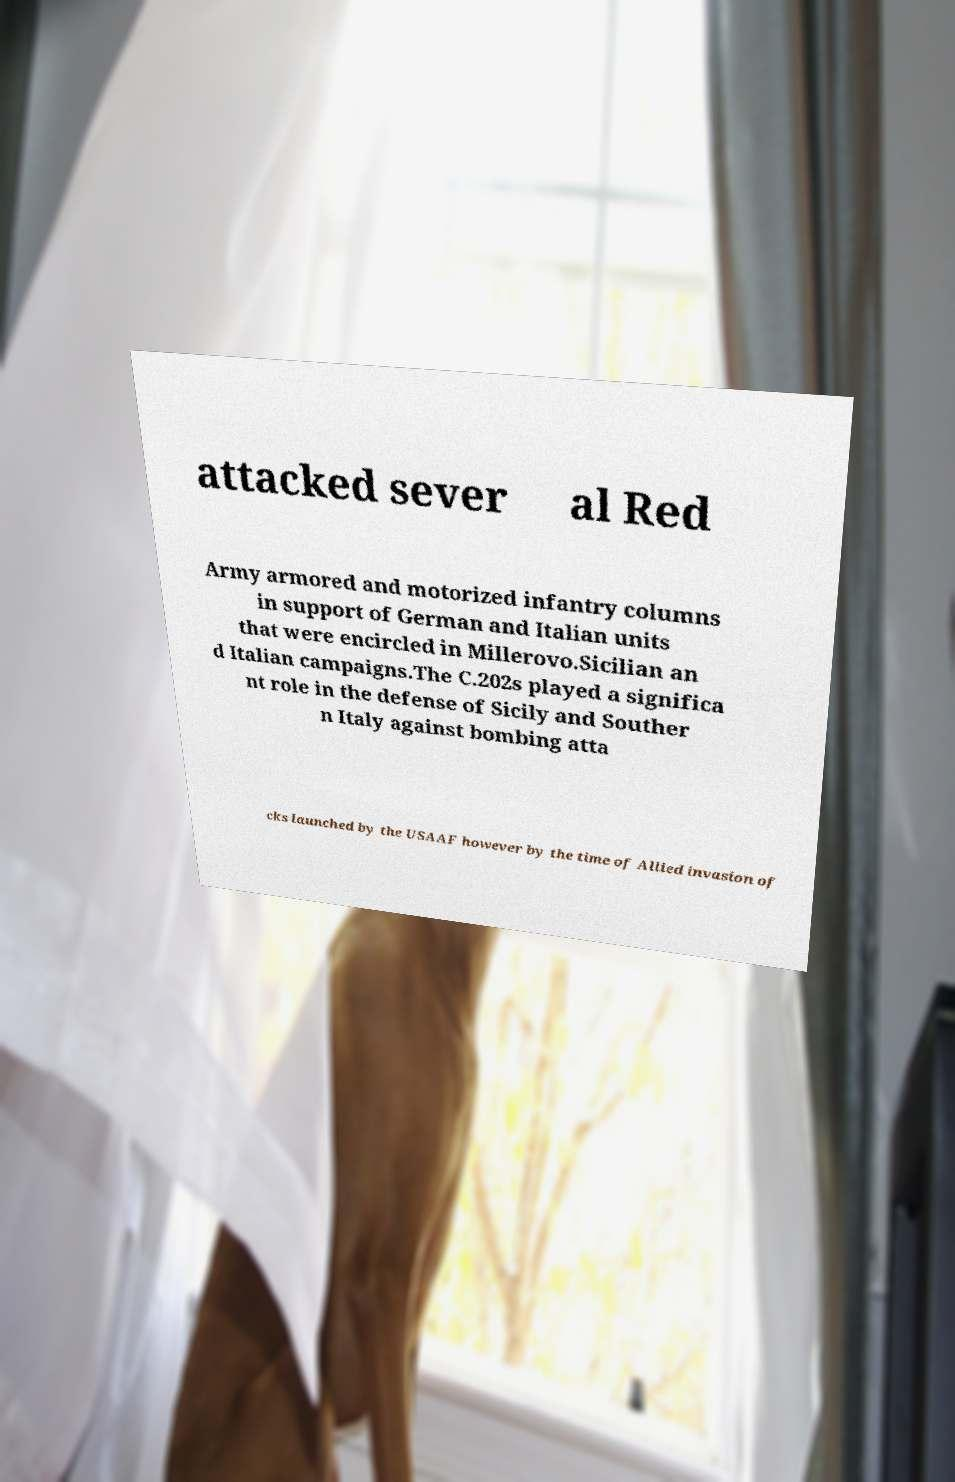Can you accurately transcribe the text from the provided image for me? attacked sever al Red Army armored and motorized infantry columns in support of German and Italian units that were encircled in Millerovo.Sicilian an d Italian campaigns.The C.202s played a significa nt role in the defense of Sicily and Souther n Italy against bombing atta cks launched by the USAAF however by the time of Allied invasion of 